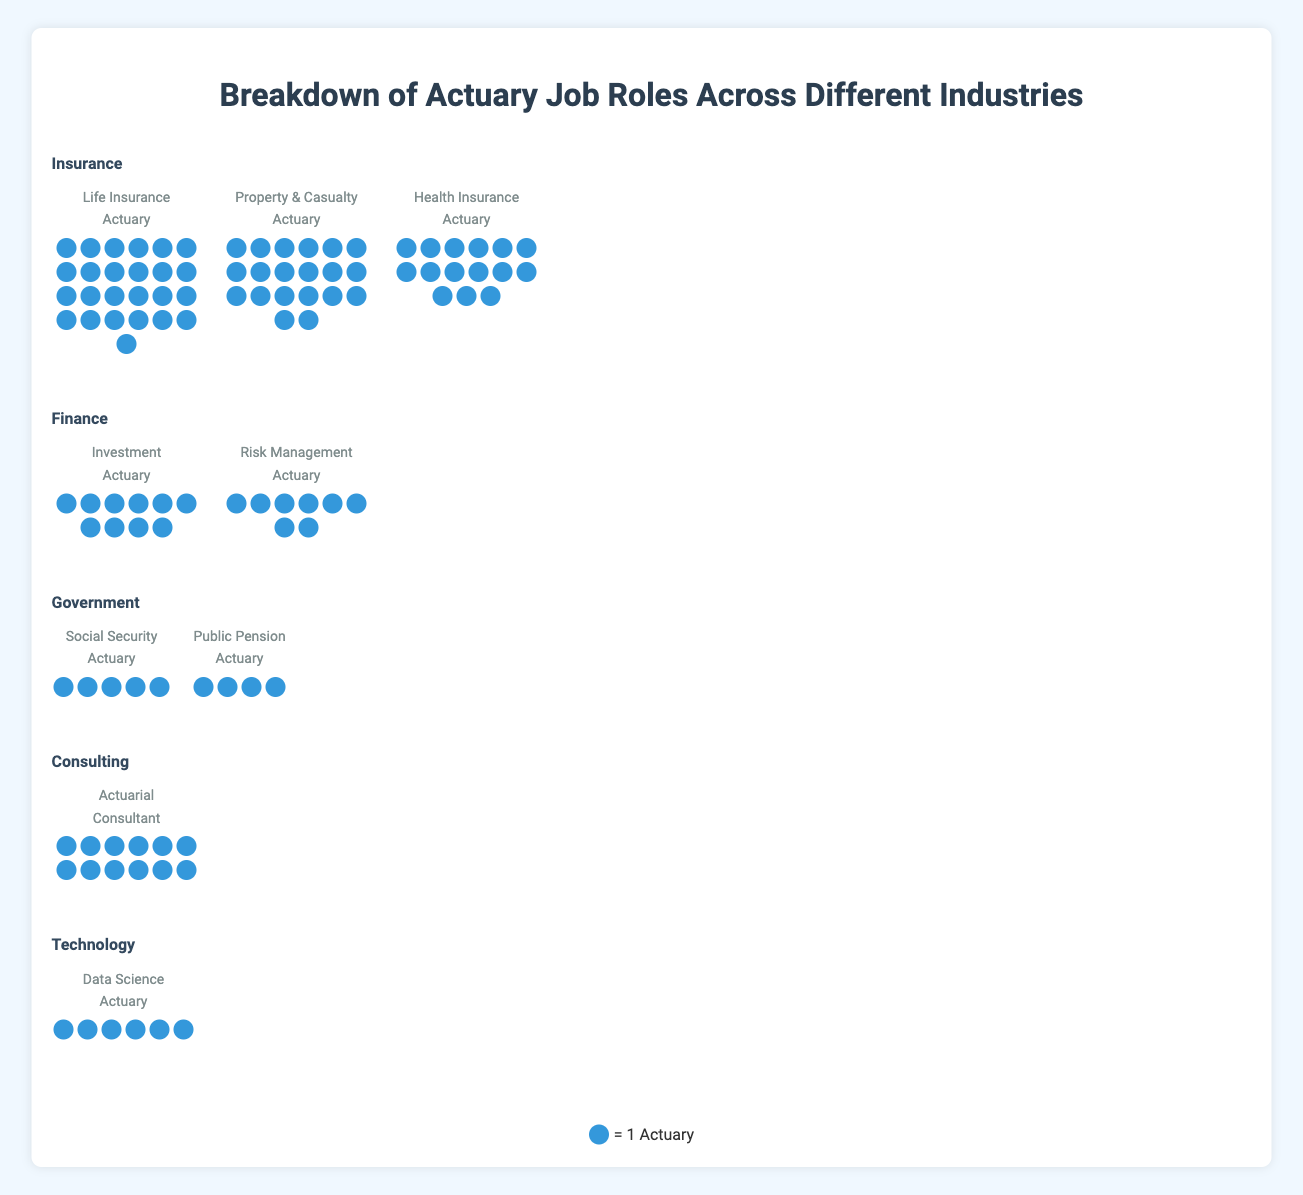What's the title of the figure? The title of the figure is displayed in a large font at the top of the figure. It helps provide context for what the figure is about.
Answer: Breakdown of Actuary Job Roles Across Different Industries How many different industries are represented in the figure? The figure shows several sections, each labeled with the name of an industry. By counting these sections, we can determine the number of industries.
Answer: 5 Which role has the most actuaries in the Insurance industry? Within the Insurance industry section, compare the number of icons for each role. The role with the most icons is the one with the highest count.
Answer: Life Insurance Actuary What is the total number of actuaries represented in the figure? Sum the counts of actuaries for all roles across all industries. This involves adding the counts provided for each role in the data.
Answer: 105 Which industry has the fewest number of actuaries? Compare the total number of actuaries in each industry by summing the counts of roles within each industry and find the smallest total.
Answer: Government Which role has exactly 6 actuaries? Look at the counts of actuaries for each role and identify the role with a count of 6.
Answer: Data Science Actuary How many industries have more than one role? Check each industry to see if it lists more than one role and count how many industries meet this criterion.
Answer: 3 (Insurance, Finance, Government) 